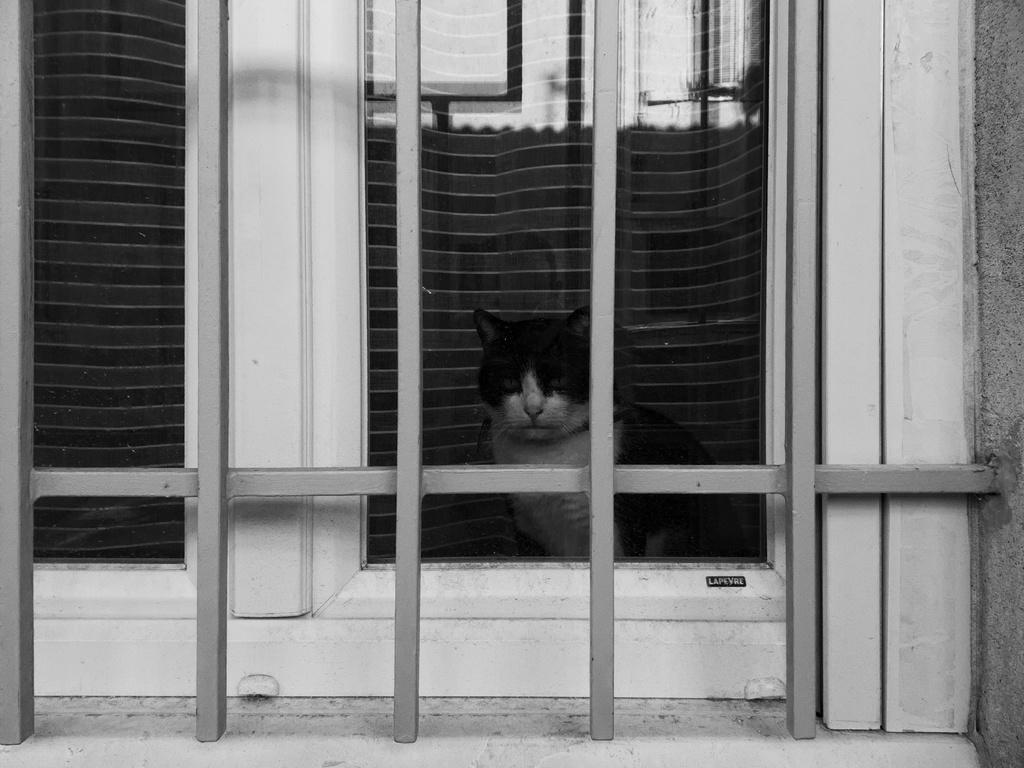What is the color scheme of the image? The image is black and white. What animal can be seen in the image? There is a cat in the image. Where is the cat located in relation to other objects in the image? The cat is in front of a window. Reasoning: Let' Let's think step by step in order to produce the conversation. We start by identifying the color scheme of the image, which is black and white. Then, we focus on the main subject of the image, which is the cat. Finally, we describe the cat's location in relation to other objects in the image, specifically mentioning the window. Absurd Question/Answer: What type of clover is growing in the snow in the image? There is no clover or snow present in the image; it is a black and white image featuring a cat in front of a window. 